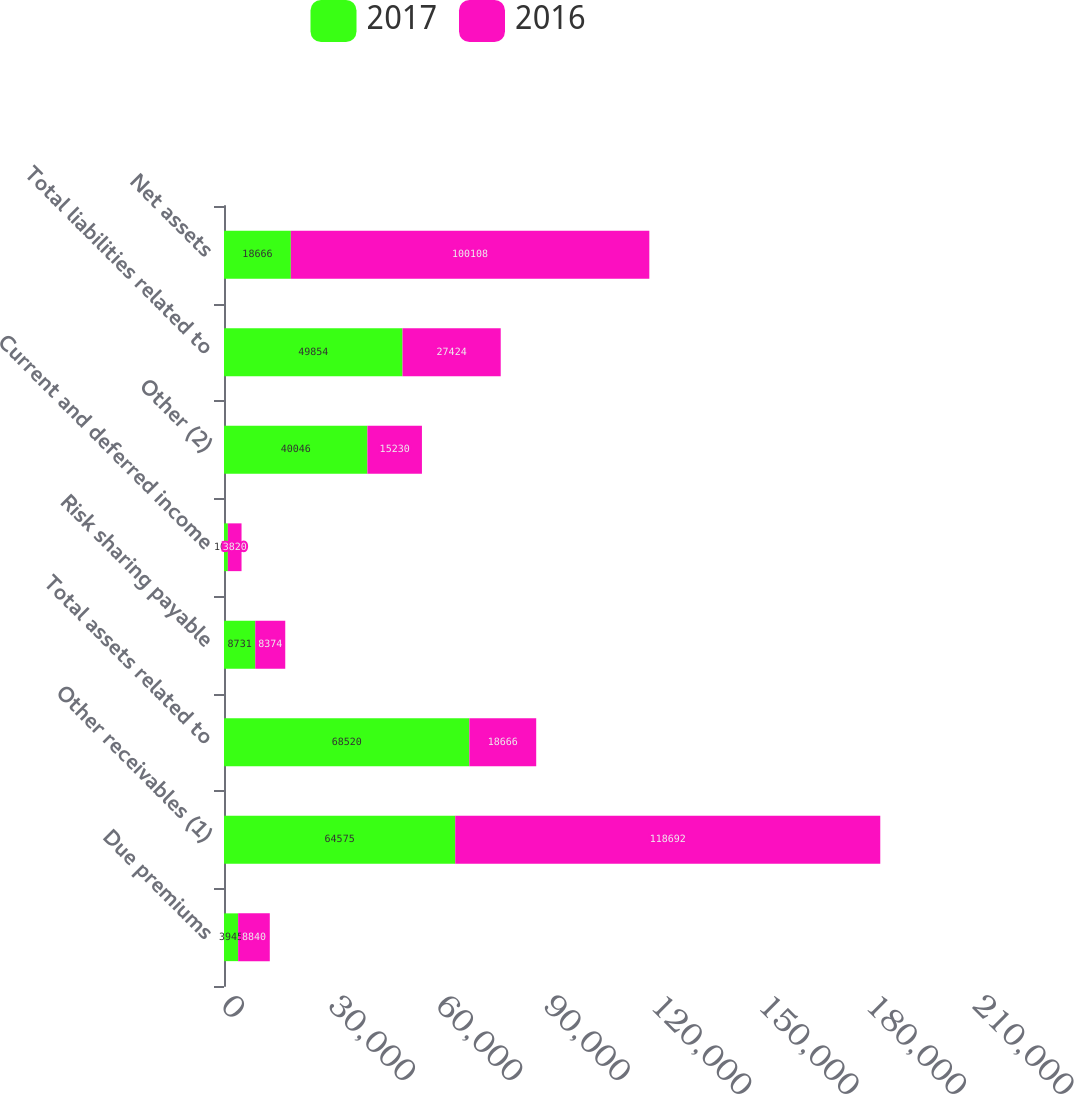<chart> <loc_0><loc_0><loc_500><loc_500><stacked_bar_chart><ecel><fcel>Due premiums<fcel>Other receivables (1)<fcel>Total assets related to<fcel>Risk sharing payable<fcel>Current and deferred income<fcel>Other (2)<fcel>Total liabilities related to<fcel>Net assets<nl><fcel>2017<fcel>3945<fcel>64575<fcel>68520<fcel>8731<fcel>1077<fcel>40046<fcel>49854<fcel>18666<nl><fcel>2016<fcel>8840<fcel>118692<fcel>18666<fcel>8374<fcel>3820<fcel>15230<fcel>27424<fcel>100108<nl></chart> 